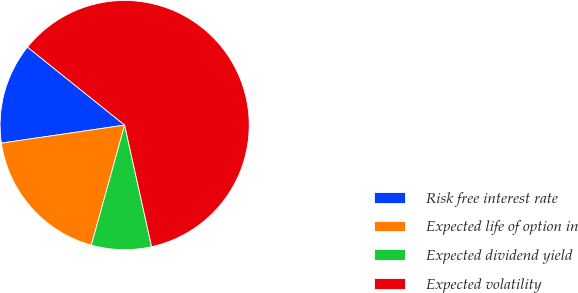<chart> <loc_0><loc_0><loc_500><loc_500><pie_chart><fcel>Risk free interest rate<fcel>Expected life of option in<fcel>Expected dividend yield<fcel>Expected volatility<nl><fcel>13.08%<fcel>18.38%<fcel>7.78%<fcel>60.76%<nl></chart> 